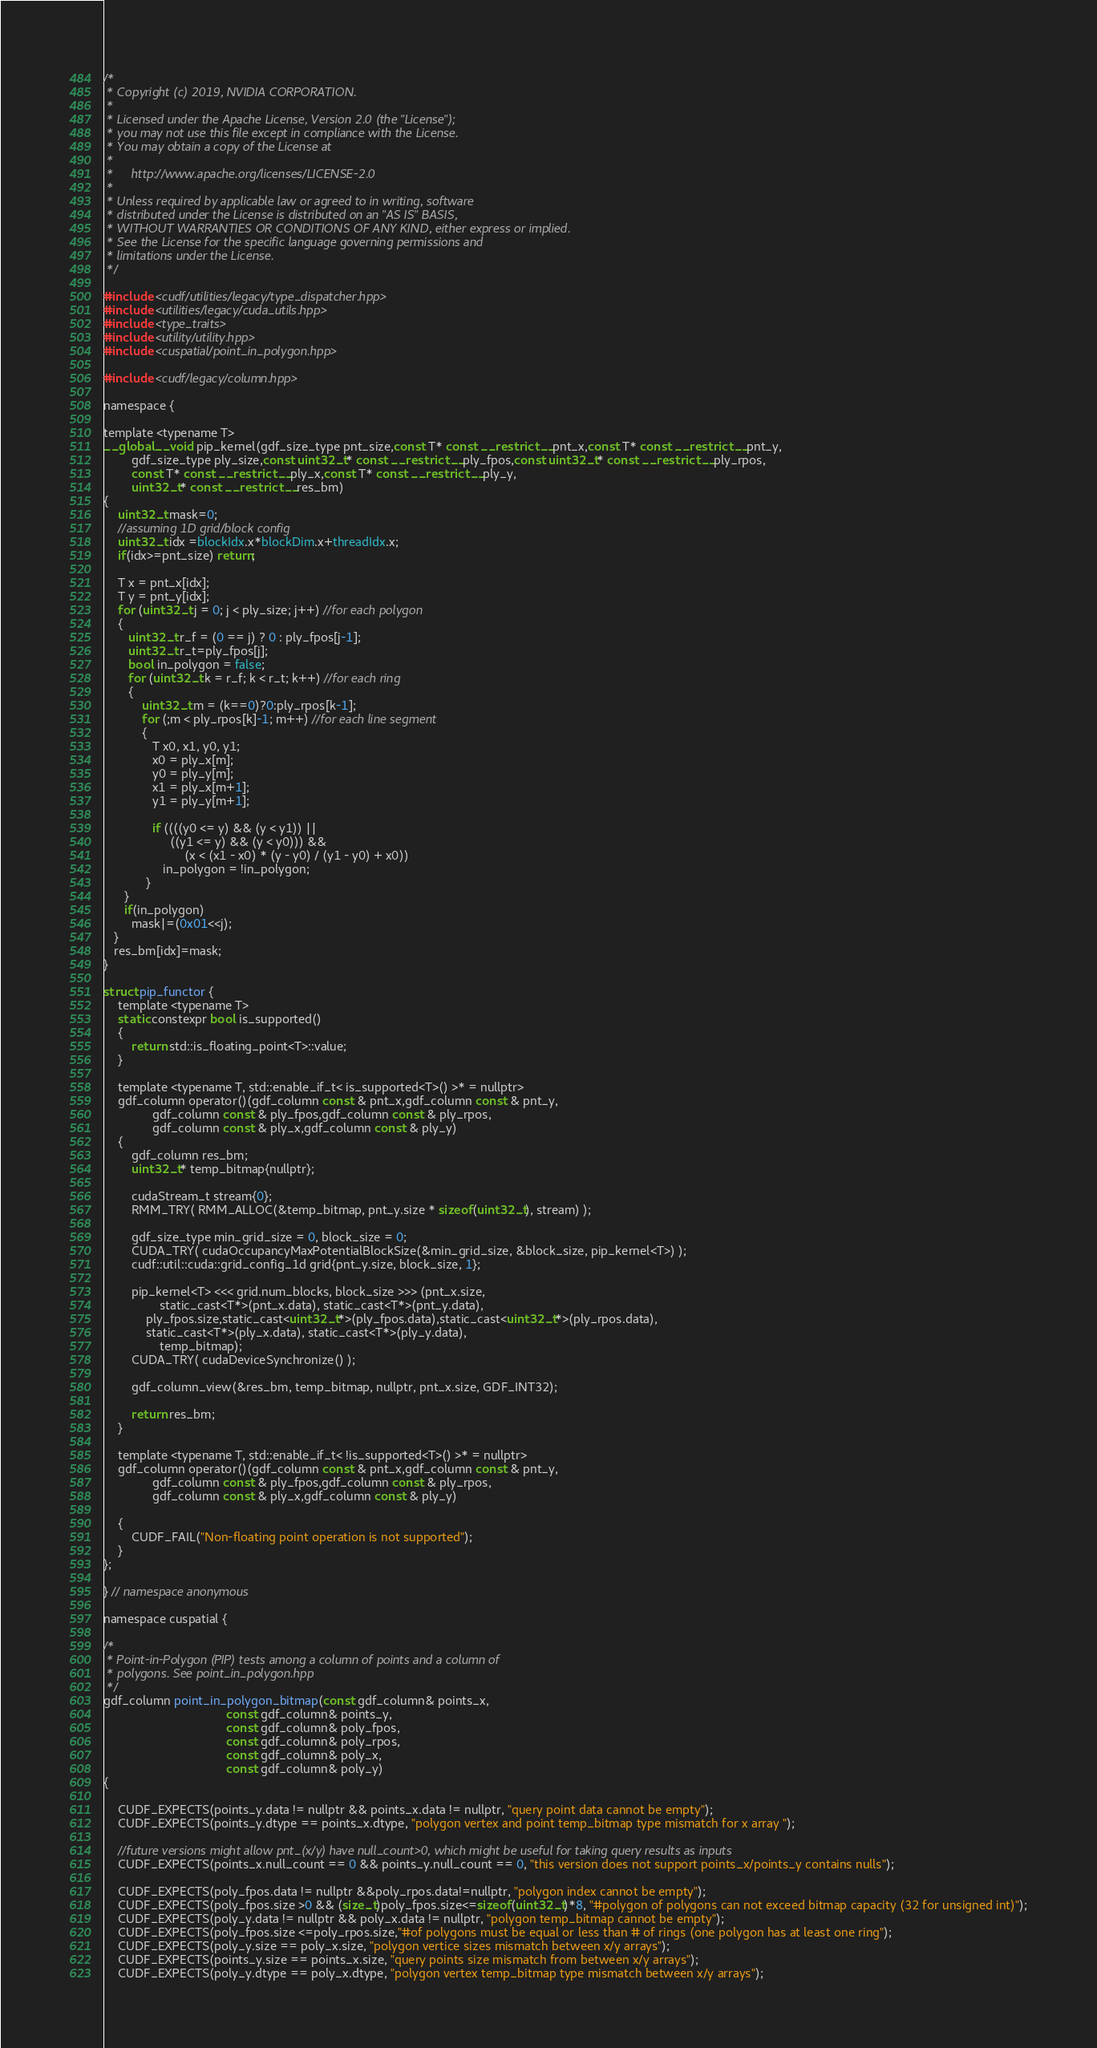<code> <loc_0><loc_0><loc_500><loc_500><_Cuda_>/*
 * Copyright (c) 2019, NVIDIA CORPORATION.
 *
 * Licensed under the Apache License, Version 2.0 (the "License");
 * you may not use this file except in compliance with the License.
 * You may obtain a copy of the License at
 *
 *     http://www.apache.org/licenses/LICENSE-2.0
 *
 * Unless required by applicable law or agreed to in writing, software
 * distributed under the License is distributed on an "AS IS" BASIS,
 * WITHOUT WARRANTIES OR CONDITIONS OF ANY KIND, either express or implied.
 * See the License for the specific language governing permissions and
 * limitations under the License.
 */

#include <cudf/utilities/legacy/type_dispatcher.hpp>
#include <utilities/legacy/cuda_utils.hpp>
#include <type_traits>
#include <utility/utility.hpp>
#include <cuspatial/point_in_polygon.hpp>

#include <cudf/legacy/column.hpp>

namespace {

template <typename T>
__global__ void pip_kernel(gdf_size_type pnt_size,const T* const __restrict__ pnt_x,const T* const __restrict__ pnt_y,
        gdf_size_type ply_size,const uint32_t* const __restrict__ ply_fpos,const uint32_t* const __restrict__ ply_rpos,
        const T* const __restrict__ ply_x,const T* const __restrict__ ply_y,
        uint32_t* const __restrict__ res_bm)
{
    uint32_t mask=0;
    //assuming 1D grid/block config
    uint32_t idx =blockIdx.x*blockDim.x+threadIdx.x;
    if(idx>=pnt_size) return;

    T x = pnt_x[idx];
    T y = pnt_y[idx];
    for (uint32_t j = 0; j < ply_size; j++) //for each polygon
    {
       uint32_t r_f = (0 == j) ? 0 : ply_fpos[j-1];
       uint32_t r_t=ply_fpos[j];
       bool in_polygon = false;
       for (uint32_t k = r_f; k < r_t; k++) //for each ring
       {
           uint32_t m = (k==0)?0:ply_rpos[k-1];
           for (;m < ply_rpos[k]-1; m++) //for each line segment
           {
              T x0, x1, y0, y1;
              x0 = ply_x[m];
              y0 = ply_y[m];
              x1 = ply_x[m+1];
              y1 = ply_y[m+1];

              if ((((y0 <= y) && (y < y1)) ||
                   ((y1 <= y) && (y < y0))) &&
                       (x < (x1 - x0) * (y - y0) / (y1 - y0) + x0))
                 in_polygon = !in_polygon;
            }
      }
      if(in_polygon)
      	mask|=(0x01<<j);
   }
   res_bm[idx]=mask;
}

struct pip_functor {
    template <typename T>
    static constexpr bool is_supported()
    {
        return std::is_floating_point<T>::value;
    }

    template <typename T, std::enable_if_t< is_supported<T>() >* = nullptr>
    gdf_column operator()(gdf_column const & pnt_x,gdf_column const & pnt_y,
 			  gdf_column const & ply_fpos,gdf_column const & ply_rpos,
			  gdf_column const & ply_x,gdf_column const & ply_y)
    {
        gdf_column res_bm;
        uint32_t* temp_bitmap{nullptr};

        cudaStream_t stream{0};
        RMM_TRY( RMM_ALLOC(&temp_bitmap, pnt_y.size * sizeof(uint32_t), stream) );

        gdf_size_type min_grid_size = 0, block_size = 0;
        CUDA_TRY( cudaOccupancyMaxPotentialBlockSize(&min_grid_size, &block_size, pip_kernel<T>) );
        cudf::util::cuda::grid_config_1d grid{pnt_y.size, block_size, 1};

        pip_kernel<T> <<< grid.num_blocks, block_size >>> (pnt_x.size,
               	static_cast<T*>(pnt_x.data), static_cast<T*>(pnt_y.data),
        	ply_fpos.size,static_cast<uint32_t*>(ply_fpos.data),static_cast<uint32_t*>(ply_rpos.data),
        	static_cast<T*>(ply_x.data), static_cast<T*>(ply_y.data),
                temp_bitmap);
        CUDA_TRY( cudaDeviceSynchronize() );

        gdf_column_view(&res_bm, temp_bitmap, nullptr, pnt_x.size, GDF_INT32);

        return res_bm;
    }

    template <typename T, std::enable_if_t< !is_supported<T>() >* = nullptr>
    gdf_column operator()(gdf_column const & pnt_x,gdf_column const & pnt_y,
 			  gdf_column const & ply_fpos,gdf_column const & ply_rpos,
			  gdf_column const & ply_x,gdf_column const & ply_y)

    {
        CUDF_FAIL("Non-floating point operation is not supported");
    }
};

} // namespace anonymous

namespace cuspatial {

/*
 * Point-in-Polygon (PIP) tests among a column of points and a column of
 * polygons. See point_in_polygon.hpp
 */
gdf_column point_in_polygon_bitmap(const gdf_column& points_x,
                                   const gdf_column& points_y,
                                   const gdf_column& poly_fpos,
                                   const gdf_column& poly_rpos,
                                   const gdf_column& poly_x,
                                   const gdf_column& poly_y)
{

    CUDF_EXPECTS(points_y.data != nullptr && points_x.data != nullptr, "query point data cannot be empty");
    CUDF_EXPECTS(points_y.dtype == points_x.dtype, "polygon vertex and point temp_bitmap type mismatch for x array ");

    //future versions might allow pnt_(x/y) have null_count>0, which might be useful for taking query results as inputs
    CUDF_EXPECTS(points_x.null_count == 0 && points_y.null_count == 0, "this version does not support points_x/points_y contains nulls");

    CUDF_EXPECTS(poly_fpos.data != nullptr &&poly_rpos.data!=nullptr, "polygon index cannot be empty");
    CUDF_EXPECTS(poly_fpos.size >0 && (size_t)poly_fpos.size<=sizeof(uint32_t)*8, "#polygon of polygons can not exceed bitmap capacity (32 for unsigned int)");
    CUDF_EXPECTS(poly_y.data != nullptr && poly_x.data != nullptr, "polygon temp_bitmap cannot be empty");
    CUDF_EXPECTS(poly_fpos.size <=poly_rpos.size,"#of polygons must be equal or less than # of rings (one polygon has at least one ring");
    CUDF_EXPECTS(poly_y.size == poly_x.size, "polygon vertice sizes mismatch between x/y arrays");
    CUDF_EXPECTS(points_y.size == points_x.size, "query points size mismatch from between x/y arrays");
    CUDF_EXPECTS(poly_y.dtype == poly_x.dtype, "polygon vertex temp_bitmap type mismatch between x/y arrays");</code> 